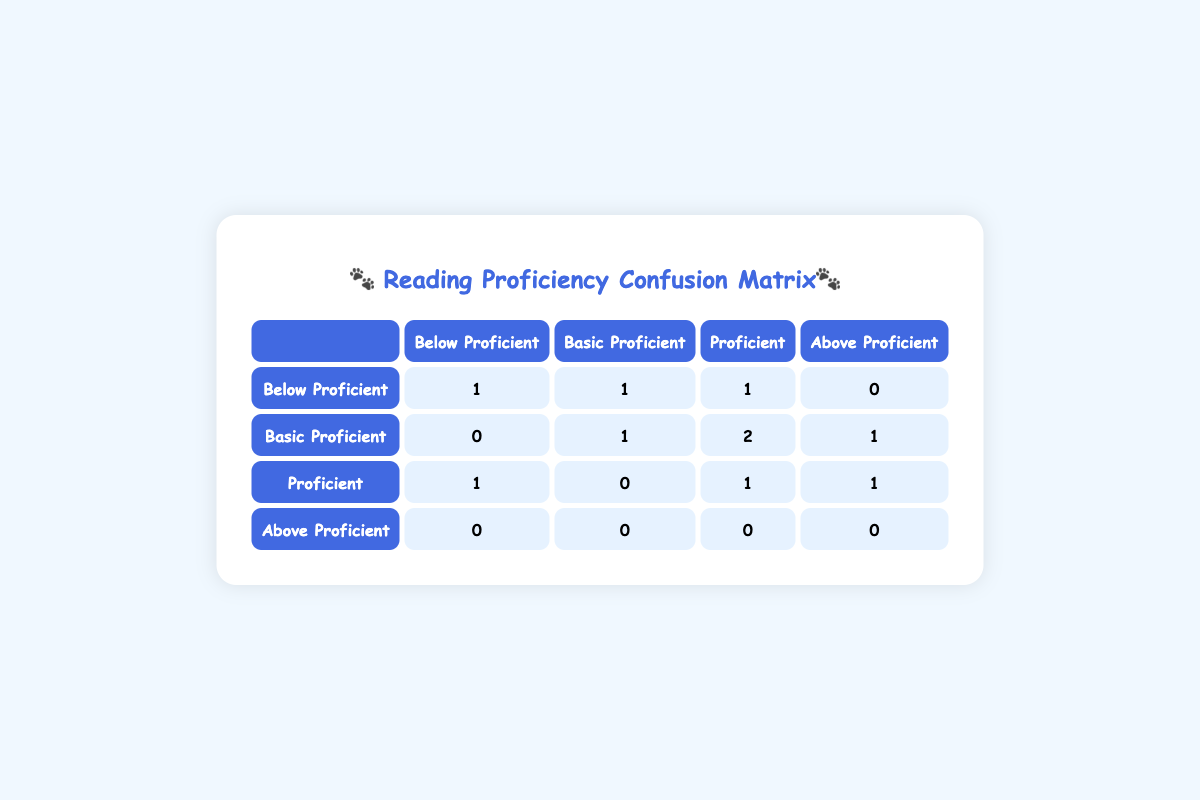What is the count of children who were classified as Below Proficient before the sessions? From the table, navigate to the row corresponding to "Below Proficient" under "Before Session". The count of children is found by adding the values in that row: 1 (Below Proficient) + 1 (Basic Proficient) + 1 (Proficient) + 0 (Above Proficient) = 3. Thus, there are 3 in total.
Answer: 3 How many children improved their proficiency from Below Proficient to Proficient? To answer this, check the "Before Session" and "After Session" columns for children. One child started as Below Proficient and ended as Proficient (Child ID 1). There are no other children who made this improvement, so the total is 1.
Answer: 1 What is the total number of children who remained at the Basic Proficient level? Examine the row for "Basic Proficient" in the "After Session" category. By looking at the data, only the child who was Basic Proficient before stayed in that category after the sessions, which is 1.
Answer: 1 Did any child move from Proficient to Below Proficient after the session? Check the "Proficient" row in the "Before Session" column and look for any moves to "Below Proficient" in the "After Session" column. There is one child who went down to Below Proficient (Child ID 9). So, the answer is yes.
Answer: Yes What is the total number of proficiency classes represented in the table? Count all unique proficiency classification levels present in the "Before Session" and "After Session". The classifications are Below Proficient, Basic Proficient, Proficient, and Above Proficient. There are 4 unique classes.
Answer: 4 How many children improved their proficiency after therapy dog sessions? Look across both the "Before Session" and "After Session" columns to see improvements. Children who increased proficiency include: Child ID 1 (Below to Proficient), Child ID 2 (Basic to Proficient), Child ID 6 (Basic to Above), Child ID 10 (Basic to Proficient), and Child ID 8 (Proficient to Above). Adding these improvements yields 5 children.
Answer: 5 What is the number of children who maintained their skill level in Basic Proficient? In the table, look for children who were classified as Basic Proficient before and still remained Basic Proficient afterward. Referring to the "Basic Proficient" row, only one child (ID 4) fits this category.
Answer: 1 Which classification had the highest number of children before the therapy sessions? To find this, look through each "Before Session" category and collect totals from each row: Below Proficient (3), Basic Proficient (3), Proficient (2), Above Proficient (0). Both Below and Basic Proficient have the highest count of 3 children.
Answer: Below Proficient and Basic Proficient How many children moved up to Above Proficient after the sessions? Reference the "After Session" category to see which children achieved Above Proficient status. Only one child moved from Proficient to Above Proficient (Child ID 8). Therefore, the response is 1 child.
Answer: 1 